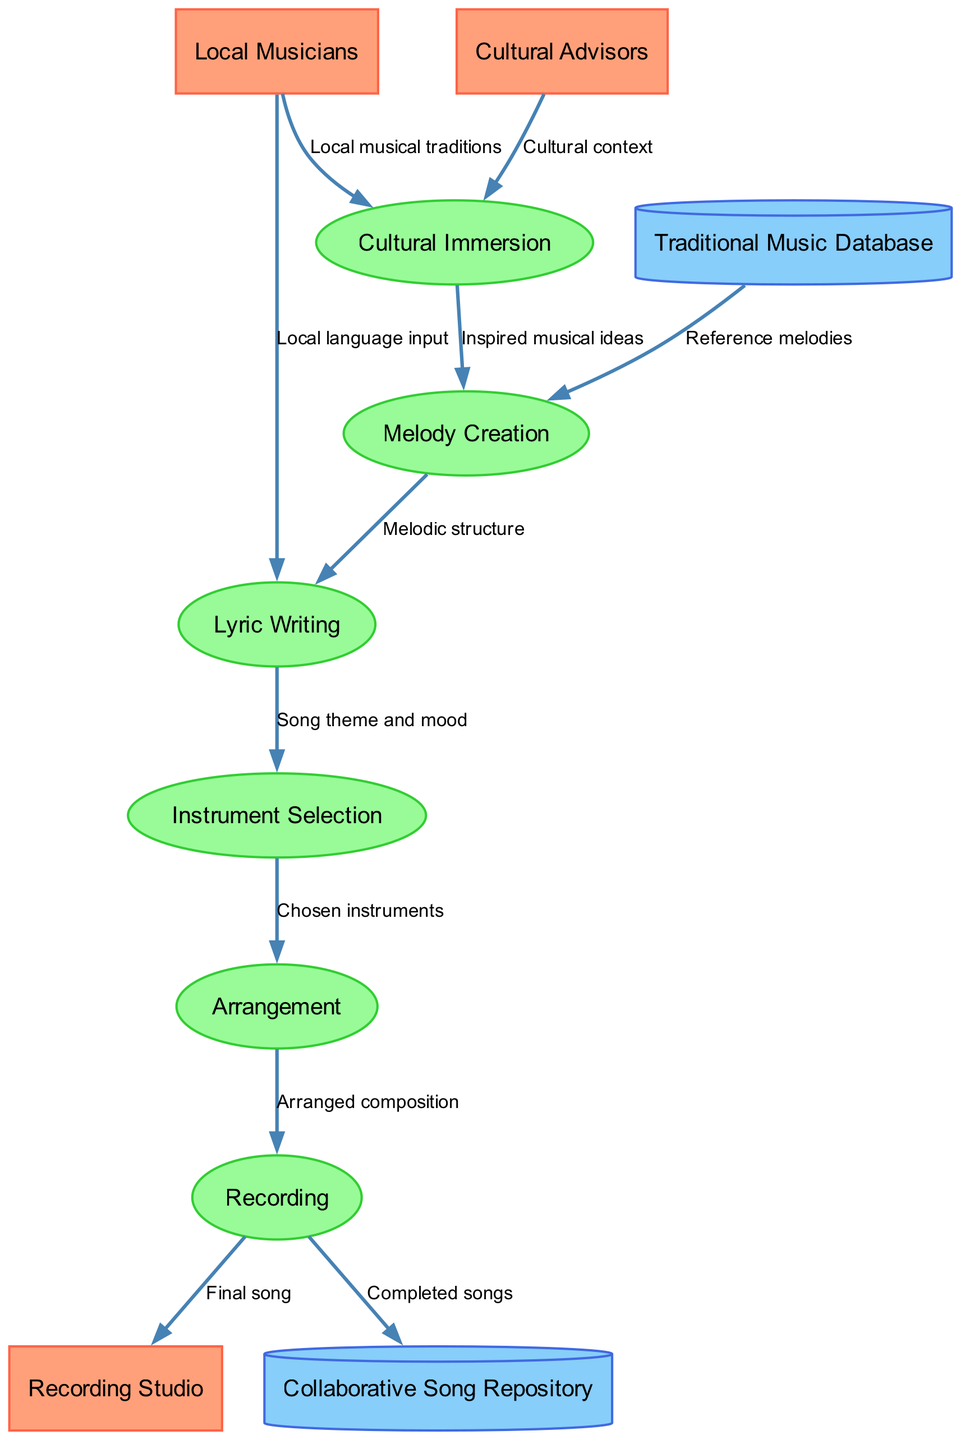What are the external entities in the diagram? The diagram lists three external entities: Local Musicians, Cultural Advisors, and Recording Studio. These entities are represented as rectangles at the top of the diagram, indicating they are sources or sinks in the collaborative songwriting process.
Answer: Local Musicians, Cultural Advisors, Recording Studio How many processes are shown in the diagram? There are six processes represented in the diagram, indicated by the ellipses that illustrate the stages in the collaborative songwriting process. These processes are Cultural Immersion, Melody Creation, Lyric Writing, Instrument Selection, Arrangement, and Recording.
Answer: 6 What is the first data flow from Local Musicians? The first data flow from Local Musicians goes to the process labeled Cultural Immersion, and it is labeled "Local musical traditions." This indicates that local musicians provide insights into their musical heritage at the start of the process.
Answer: Local musical traditions Which process utilizes the Traditional Music Database? Traditional Music Database is utilized in the process of Melody Creation. This is indicated by the data flow going from the database to the Melody Creation process, labeled as "Reference melodies," which means the process draws inspiration from traditional music references.
Answer: Melody Creation Describe the relationship between Lyric Writing and Instrument Selection. The relationship is that Lyric Writing provides input about the song's theme and mood, which informs the Instrument Selection process. This flow shows how the emotional and thematic elements of the song influence the choice of instruments, linking the two processes effectively.
Answer: Song theme and mood What is the final output of the Recording process? The final output of the Recording process is labeled as "Final song," which is directed towards the Recording Studio. This output represents the completed musical piece ready for production and distribution, marking the culmination of the collaborative effort.
Answer: Final song Which process follows Melody Creation? The process that follows Melody Creation is Lyric Writing. This flow indicates a sequential progression where, after creating the melody, the team moves on to developing lyrics that fit the melodic structure.
Answer: Lyric Writing How many data stores are present in the diagram? There are two data stores present in the diagram, indicated by the cylindrical shapes. These are Traditional Music Database and Collaborative Song Repository, serving as repositories of information and completed works.
Answer: 2 What flows into the Arrangement process? The Arrangement process receives input labeled "Chosen instruments" from the Instrument Selection process. This indicates that decisions made during instrument selection directly inform how the song will be arranged.
Answer: Chosen instruments 